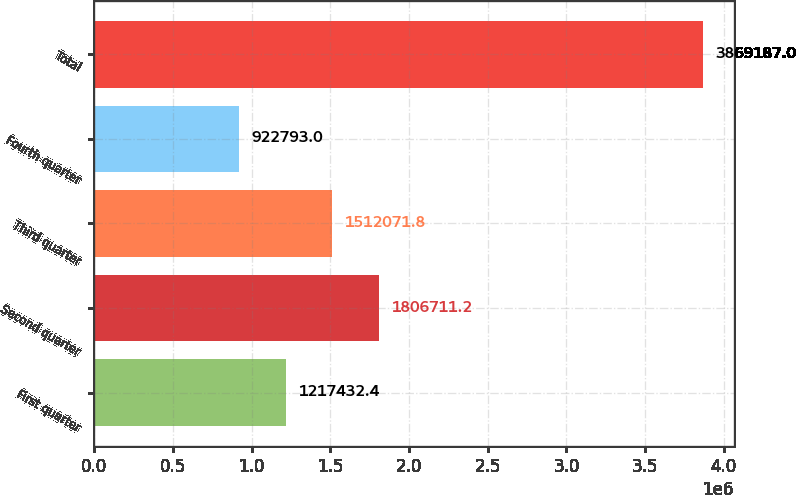Convert chart to OTSL. <chart><loc_0><loc_0><loc_500><loc_500><bar_chart><fcel>First quarter<fcel>Second quarter<fcel>Third quarter<fcel>Fourth quarter<fcel>Total<nl><fcel>1.21743e+06<fcel>1.80671e+06<fcel>1.51207e+06<fcel>922793<fcel>3.86919e+06<nl></chart> 